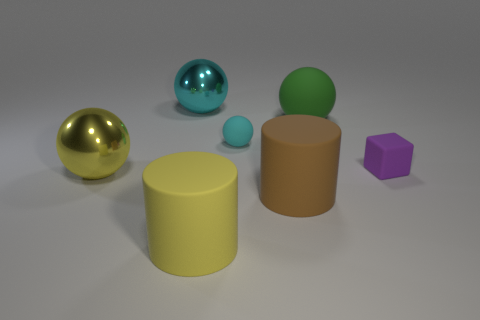The big green object that is made of the same material as the large yellow cylinder is what shape?
Give a very brief answer. Sphere. What number of big yellow metallic things have the same shape as the big green object?
Keep it short and to the point. 1. There is a tiny matte object that is on the right side of the big green rubber sphere; does it have the same shape as the cyan object that is behind the large green matte sphere?
Offer a very short reply. No. What number of objects are either small cyan matte spheres or rubber cylinders that are on the right side of the large cyan metal thing?
Your response must be concise. 3. What shape is the big shiny object that is the same color as the small sphere?
Your answer should be very brief. Sphere. What number of other objects have the same size as the purple matte object?
Provide a succinct answer. 1. How many yellow things are tiny matte objects or big cylinders?
Give a very brief answer. 1. The small rubber thing behind the tiny rubber thing on the right side of the small cyan matte thing is what shape?
Provide a succinct answer. Sphere. The cyan thing that is the same size as the purple rubber block is what shape?
Keep it short and to the point. Sphere. Are there any large shiny objects that have the same color as the tiny matte sphere?
Your response must be concise. Yes. 